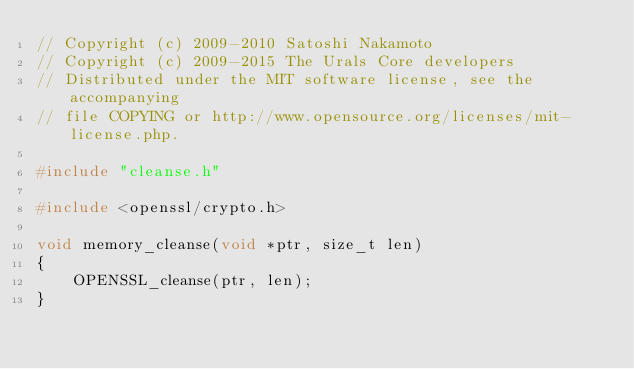Convert code to text. <code><loc_0><loc_0><loc_500><loc_500><_C++_>// Copyright (c) 2009-2010 Satoshi Nakamoto
// Copyright (c) 2009-2015 The Urals Core developers
// Distributed under the MIT software license, see the accompanying
// file COPYING or http://www.opensource.org/licenses/mit-license.php.

#include "cleanse.h"

#include <openssl/crypto.h>

void memory_cleanse(void *ptr, size_t len)
{
    OPENSSL_cleanse(ptr, len);
}
</code> 